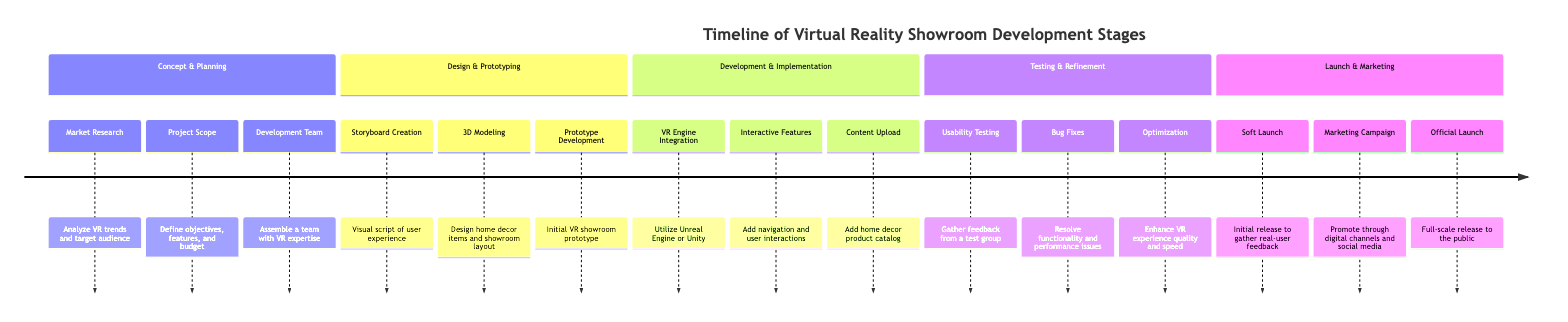What is the first stage in the timeline? The first stage listed in the timeline is "Concept & Planning." This is found at the top of the timeline and is the first section that outlines the initial steps in developing the virtual reality showroom.
Answer: Concept & Planning How many stages are there in total? There are five stages in total. Each stage represents a significant phase in the development process and is listed sequentially from Concept & Planning to Launch & Marketing.
Answer: Five What is the last key milestone mentioned? The last key milestone in the timeline is "Official Launch," which is found in the final stage of the timeline regarding the release of the virtual reality showroom to the public.
Answer: Official Launch Which key milestone comes after "Bug Fixes"? The key milestone that follows "Bug Fixes" is "Optimization." This progression indicates the steps taken after resolving initial issues, aiming to enhance the VR experience.
Answer: Optimization Which section involves 3D Modeling? The section that includes 3D Modeling is "Design & Prototyping." This section is focused on the design aspects of the virtual reality showroom.
Answer: Design & Prototyping What development engine is mentioned in the timeline? The development engines mentioned are "Unreal Engine" or "Unity." They are specified during the Development & Implementation stage for integrating the VR engine.
Answer: Unreal Engine or Unity Which stage includes "Usability Testing"? "Usability Testing" is included in the "Testing & Refinement" stage of the timeline. This stage is crucial for gathering user feedback on the virtual reality experience.
Answer: Testing & Refinement What is the purpose of the "Soft Launch"? The purpose of the "Soft Launch" is to gather real-user feedback. This step allows for initial reactions and insights from users before the full-scale release.
Answer: Gather real-user feedback Which milestone is directly before "Marketing Campaign"? The milestone directly before "Marketing Campaign" is "Soft Launch." This indicates the sequence of activities leading up to the marketing efforts for the virtual reality showroom.
Answer: Soft Launch 